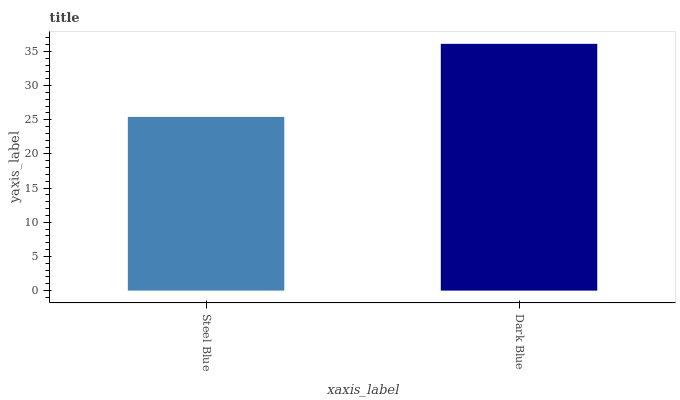Is Steel Blue the minimum?
Answer yes or no. Yes. Is Dark Blue the maximum?
Answer yes or no. Yes. Is Dark Blue the minimum?
Answer yes or no. No. Is Dark Blue greater than Steel Blue?
Answer yes or no. Yes. Is Steel Blue less than Dark Blue?
Answer yes or no. Yes. Is Steel Blue greater than Dark Blue?
Answer yes or no. No. Is Dark Blue less than Steel Blue?
Answer yes or no. No. Is Dark Blue the high median?
Answer yes or no. Yes. Is Steel Blue the low median?
Answer yes or no. Yes. Is Steel Blue the high median?
Answer yes or no. No. Is Dark Blue the low median?
Answer yes or no. No. 